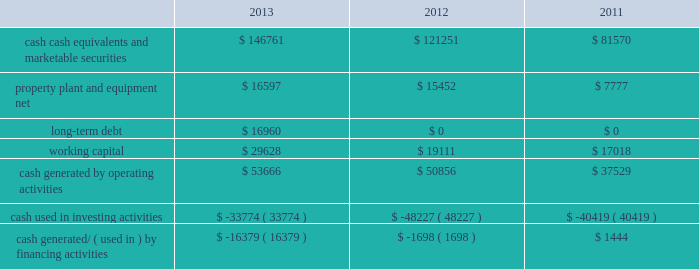Table of contents adjustments that may result from tax examinations .
However , the outcome of tax audits cannot be predicted with certainty .
If any issues addressed in the company 2019s tax audits are resolved in a manner not consistent with management 2019s expectations , the company could be required to adjust its provision for income taxes in the period such resolution occurs .
Liquidity and capital resources the table presents selected financial information and statistics as of and for the years ended september 28 , 2013 , september 29 , 2012 and september 24 , 2011 ( in millions ) : the company believes its existing balances of cash , cash equivalents and marketable securities will be sufficient to satisfy its working capital needs , capital asset purchases , outstanding commitments , and other liquidity requirements associated with its existing operations over the next 12 months .
The company anticipates the cash used for future dividends and the share repurchase program will come from its current domestic cash , cash generated from on-going u.s .
Operating activities and from borrowings .
As of september 28 , 2013 and september 29 , 2012 , $ 111.3 billion and $ 82.6 billion , respectively , of the company 2019s cash , cash equivalents and marketable securities were held by foreign subsidiaries and are generally based in u.s .
Dollar-denominated holdings .
Amounts held by foreign subsidiaries are generally subject to u.s .
Income taxation on repatriation to the u.s .
The company 2019s marketable securities investment portfolio is invested primarily in highly-rated securities and its investment policy generally limits the amount of credit exposure to any one issuer .
The policy requires investments generally to be investment grade with the objective of minimizing the potential risk of principal loss .
During 2013 , cash generated from operating activities of $ 53.7 billion was a result of $ 37.0 billion of net income , non-cash adjustments to net income of $ 10.2 billion and an increase in net change in operating assets and liabilities of $ 6.5 billion .
Cash used in investing activities of $ 33.8 billion during 2013 consisted primarily of net purchases , sales and maturities of marketable securities of $ 24.0 billion and cash used to acquire property , plant and equipment of $ 8.2 billion .
Cash used in financing activities during 2013 consisted primarily of cash used to repurchase common stock of $ 22.9 billion and cash used to pay dividends and dividend equivalent rights of $ 10.6 billion , partially offset by net proceeds from the issuance of long-term debt of $ 16.9 billion .
During 2012 , cash generated from operating activities of $ 50.9 billion was a result of $ 41.7 billion of net income and non-cash adjustments to net income of $ 9.4 billion , partially offset by a decrease in net operating assets and liabilities of $ 299 million .
Cash used in investing activities during 2012 of $ 48.2 billion consisted primarily of net purchases , sales and maturities of marketable securities of $ 38.4 billion and cash used to acquire property , plant and equipment of $ 8.3 billion .
Cash used in financing activities during 2012 of $ 1.7 billion consisted primarily of cash used to pay dividends and dividend equivalent rights of $ 2.5 billion .
Capital assets the company 2019s capital expenditures were $ 7.0 billion during 2013 , consisting of $ 499 million for retail store facilities and $ 6.5 billion for other capital expenditures , including product tooling and manufacturing process equipment , and other corporate facilities and infrastructure .
The company 2019s actual cash payments for capital expenditures during 2013 were $ 8.2 billion. .

What was the average amount in millions of long-term debt in the three year period? 
Computations: (((16960 + 0) + 0) / 3)
Answer: 5653.33333. 